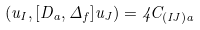<formula> <loc_0><loc_0><loc_500><loc_500>( { u } _ { I } , [ D _ { a } , \Delta _ { f } ] { u } _ { J } ) = 4 C _ { ( I J ) a }</formula> 